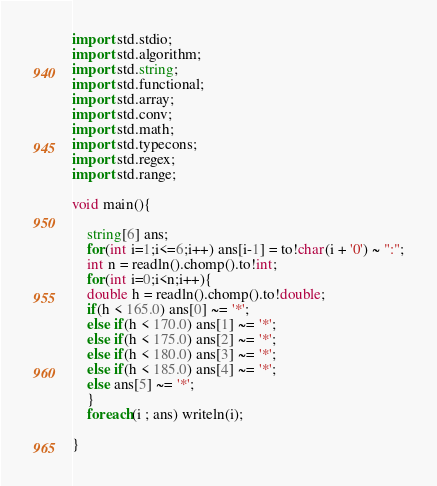Convert code to text. <code><loc_0><loc_0><loc_500><loc_500><_D_>import std.stdio;
import std.algorithm;
import std.string;
import std.functional;
import std.array;
import std.conv;
import std.math;
import std.typecons;
import std.regex;
import std.range;

void main(){

    string[6] ans;
    for(int i=1;i<=6;i++) ans[i-1] = to!char(i + '0') ~ ":";
    int n = readln().chomp().to!int;
    for(int i=0;i<n;i++){
	double h = readln().chomp().to!double;
	if(h < 165.0) ans[0] ~= '*';
	else if(h < 170.0) ans[1] ~= '*';
	else if(h < 175.0) ans[2] ~= '*';
	else if(h < 180.0) ans[3] ~= '*';
	else if(h < 185.0) ans[4] ~= '*';
	else ans[5] ~= '*';
    }
    foreach(i ; ans) writeln(i);

}</code> 